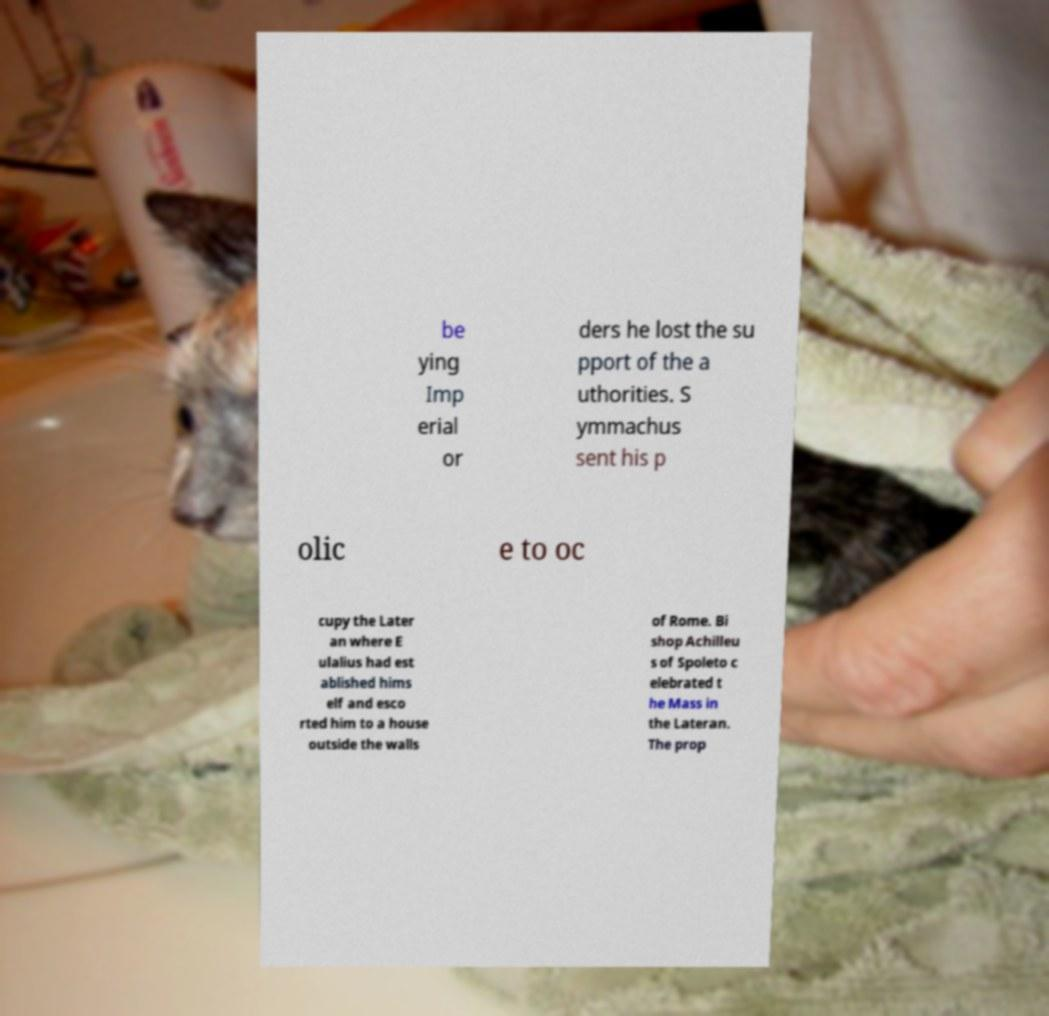What messages or text are displayed in this image? I need them in a readable, typed format. be ying Imp erial or ders he lost the su pport of the a uthorities. S ymmachus sent his p olic e to oc cupy the Later an where E ulalius had est ablished hims elf and esco rted him to a house outside the walls of Rome. Bi shop Achilleu s of Spoleto c elebrated t he Mass in the Lateran. The prop 